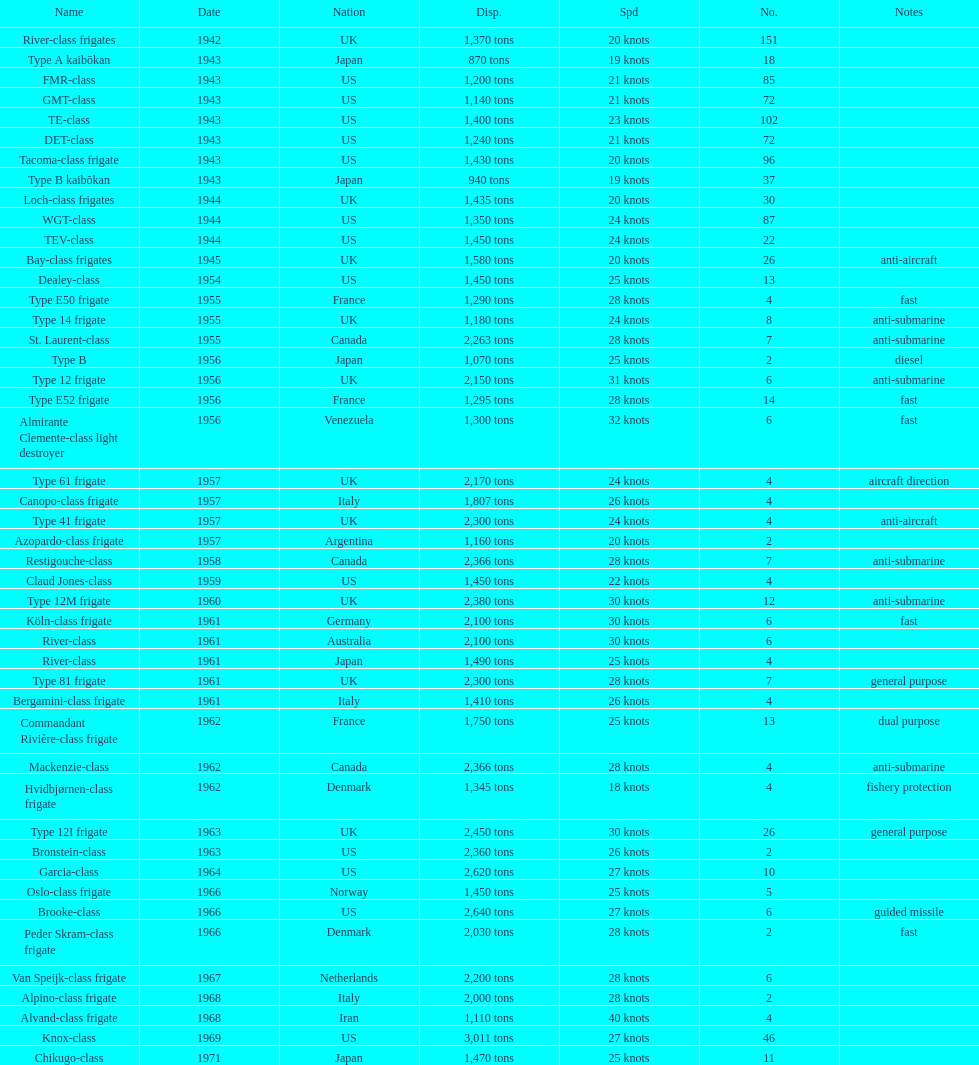Which of the boats listed is the fastest? Alvand-class frigate. 